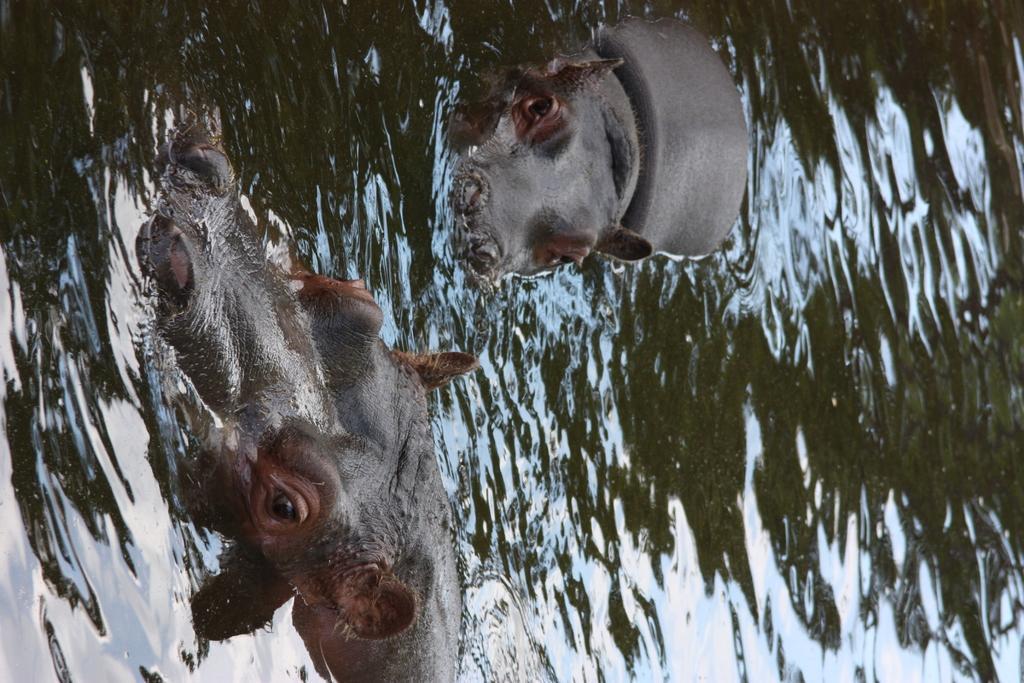Can you describe this image briefly? In this image there are two rhinoceros in the water. 